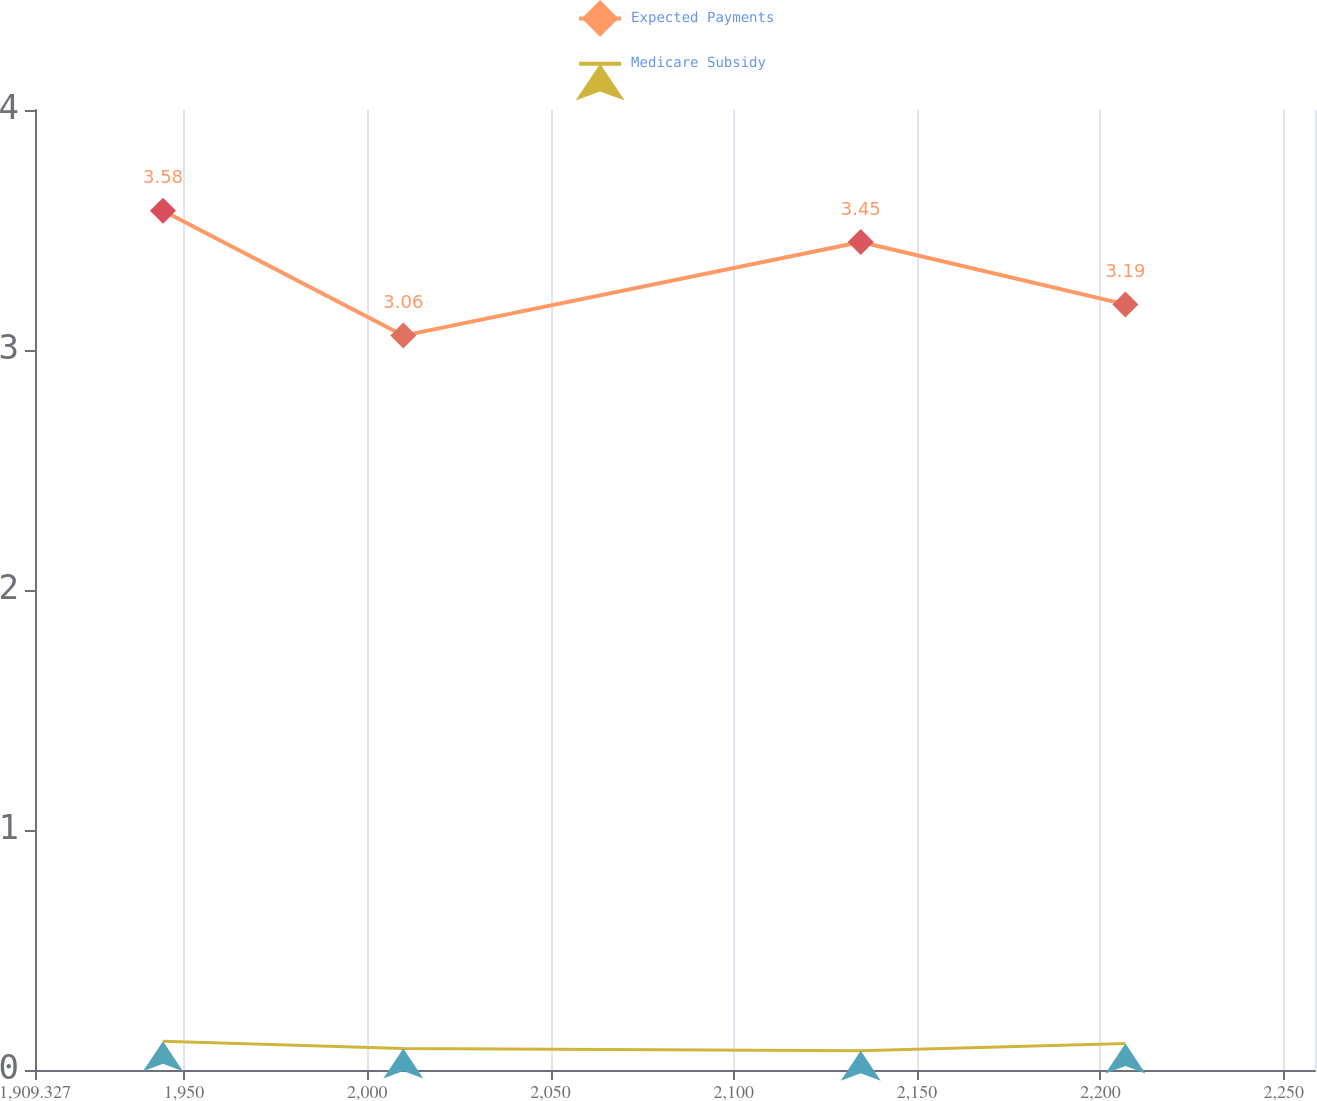<chart> <loc_0><loc_0><loc_500><loc_500><line_chart><ecel><fcel>Expected Payments<fcel>Medicare Subsidy<nl><fcel>1944.25<fcel>3.58<fcel>0.12<nl><fcel>2009.81<fcel>3.06<fcel>0.09<nl><fcel>2134.62<fcel>3.45<fcel>0.08<nl><fcel>2206.84<fcel>3.19<fcel>0.11<nl><fcel>2293.48<fcel>2.22<fcel>0.09<nl></chart> 